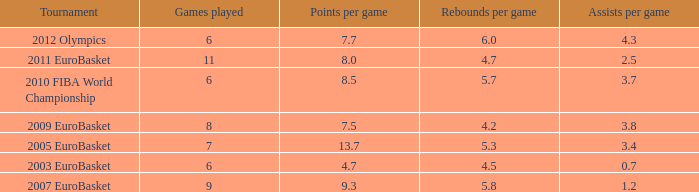How many points per game have the tournament 2005 eurobasket? 13.7. 